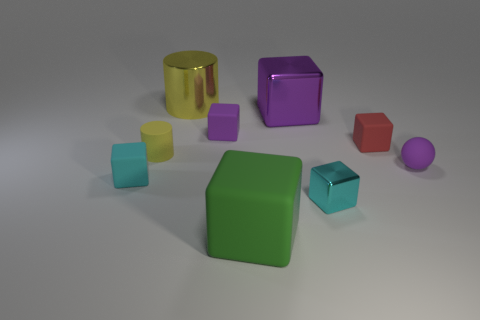Subtract 2 cubes. How many cubes are left? 4 Subtract all metallic cubes. How many cubes are left? 4 Subtract all cyan cubes. How many cubes are left? 4 Subtract all green cubes. Subtract all cyan cylinders. How many cubes are left? 5 Add 1 large blue matte objects. How many objects exist? 10 Subtract all cubes. How many objects are left? 3 Add 3 large cylinders. How many large cylinders are left? 4 Add 2 tiny shiny blocks. How many tiny shiny blocks exist? 3 Subtract 0 blue cylinders. How many objects are left? 9 Subtract all yellow cylinders. Subtract all yellow cylinders. How many objects are left? 5 